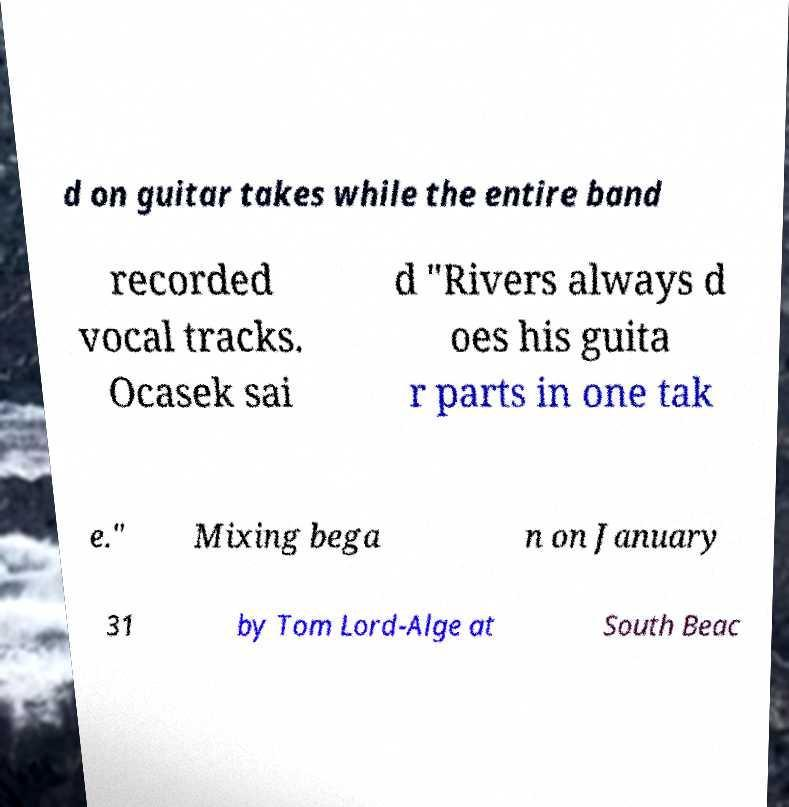For documentation purposes, I need the text within this image transcribed. Could you provide that? d on guitar takes while the entire band recorded vocal tracks. Ocasek sai d "Rivers always d oes his guita r parts in one tak e." Mixing bega n on January 31 by Tom Lord-Alge at South Beac 